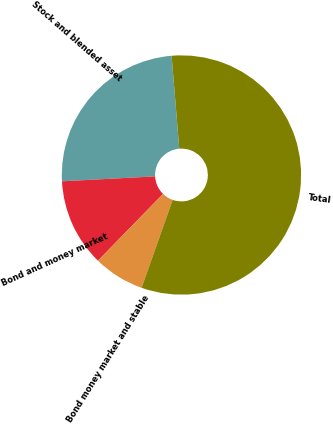<chart> <loc_0><loc_0><loc_500><loc_500><pie_chart><fcel>Stock and blended asset<fcel>Bond and money market<fcel>Bond money market and stable<fcel>Total<nl><fcel>24.53%<fcel>11.87%<fcel>6.88%<fcel>56.72%<nl></chart> 